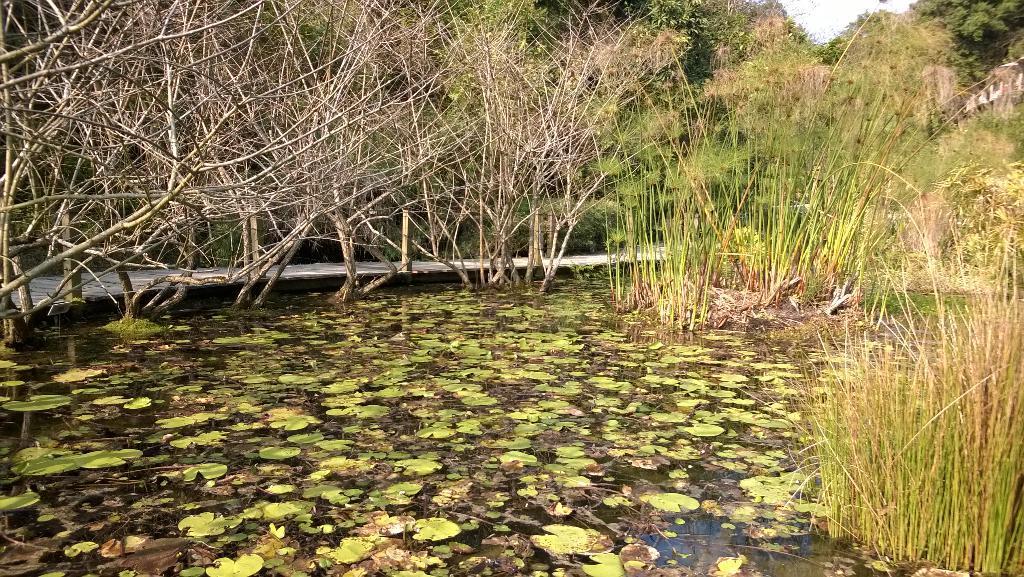Describe this image in one or two sentences. In this image there is the water. There are aquatic plants on the water. There is grass in the water. In the background there are trees. At the top there is the sky. 